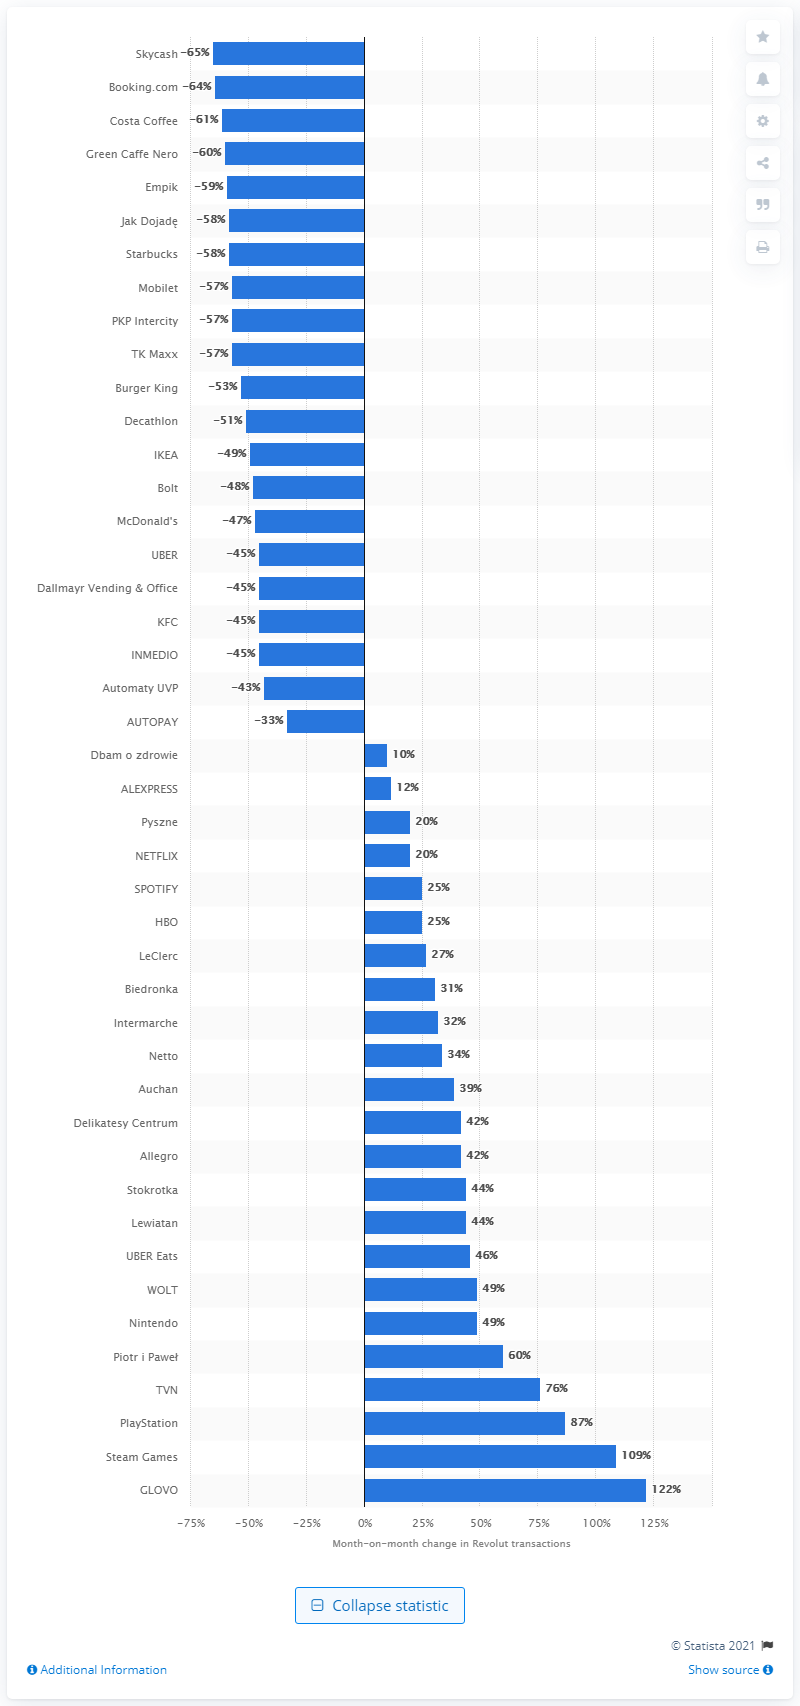Indicate a few pertinent items in this graphic. Steam Games ranked as the leader in computer games, with its exceptional user-friendly interface and vast selection of games. TVN is an example of an online streaming service. 